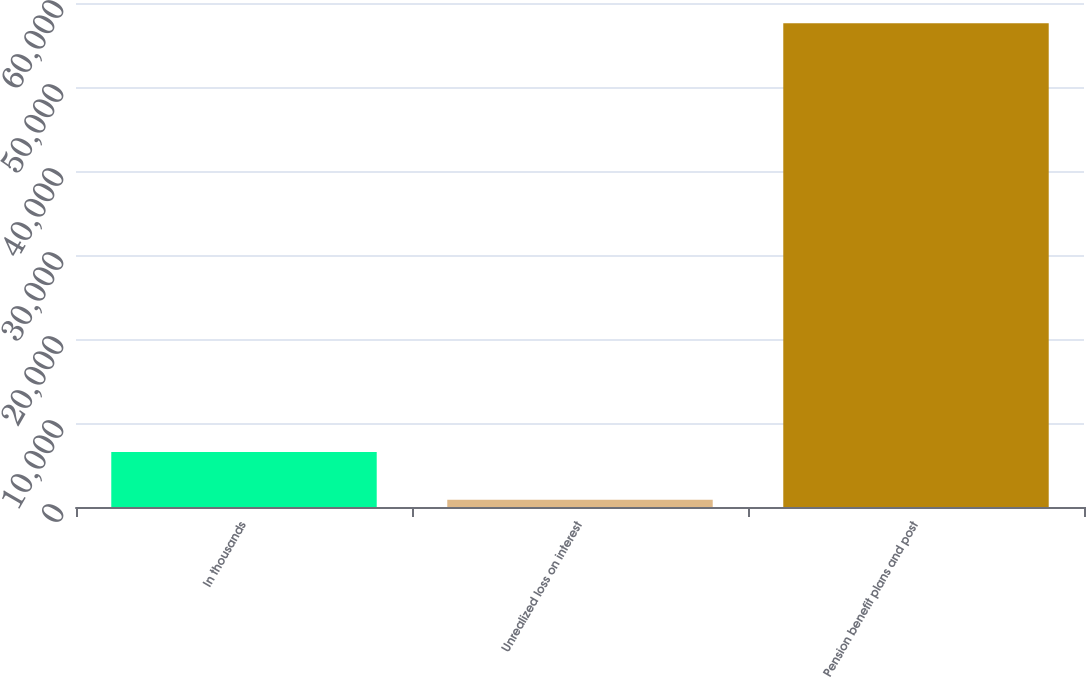<chart> <loc_0><loc_0><loc_500><loc_500><bar_chart><fcel>In thousands<fcel>Unrealized loss on interest<fcel>Pension benefit plans and post<nl><fcel>6541.8<fcel>871<fcel>57579<nl></chart> 